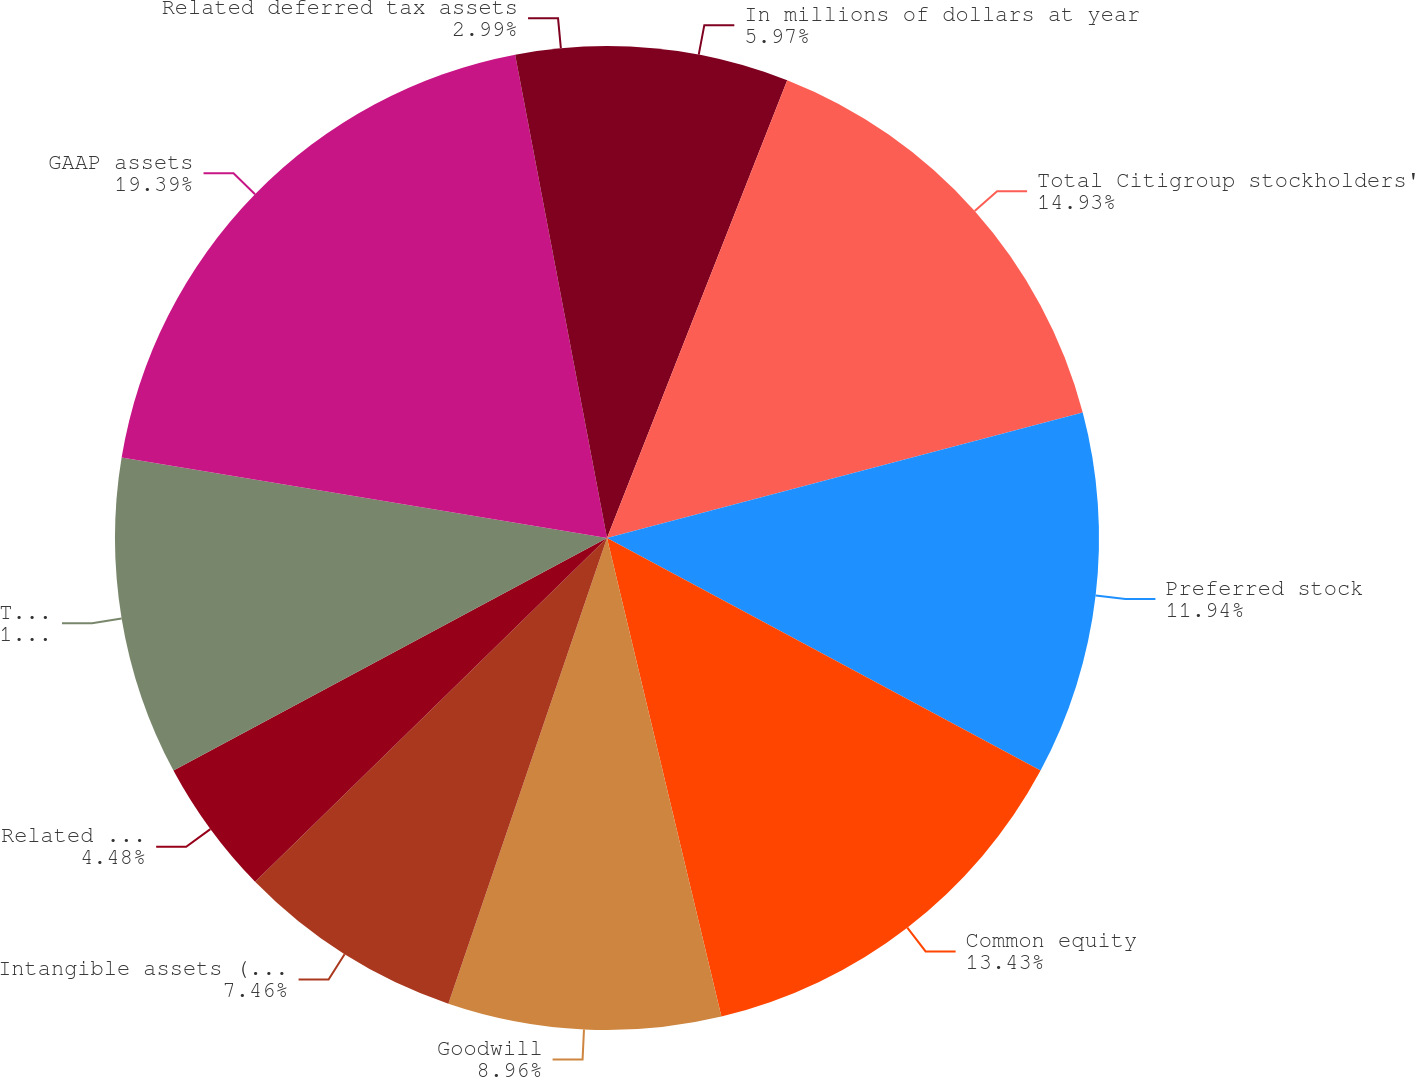Convert chart to OTSL. <chart><loc_0><loc_0><loc_500><loc_500><pie_chart><fcel>In millions of dollars at year<fcel>Total Citigroup stockholders'<fcel>Preferred stock<fcel>Common equity<fcel>Goodwill<fcel>Intangible assets (other than<fcel>Related net deferred taxes<fcel>Tangible common equity (TCE)<fcel>GAAP assets<fcel>Related deferred tax assets<nl><fcel>5.97%<fcel>14.93%<fcel>11.94%<fcel>13.43%<fcel>8.96%<fcel>7.46%<fcel>4.48%<fcel>10.45%<fcel>19.4%<fcel>2.99%<nl></chart> 